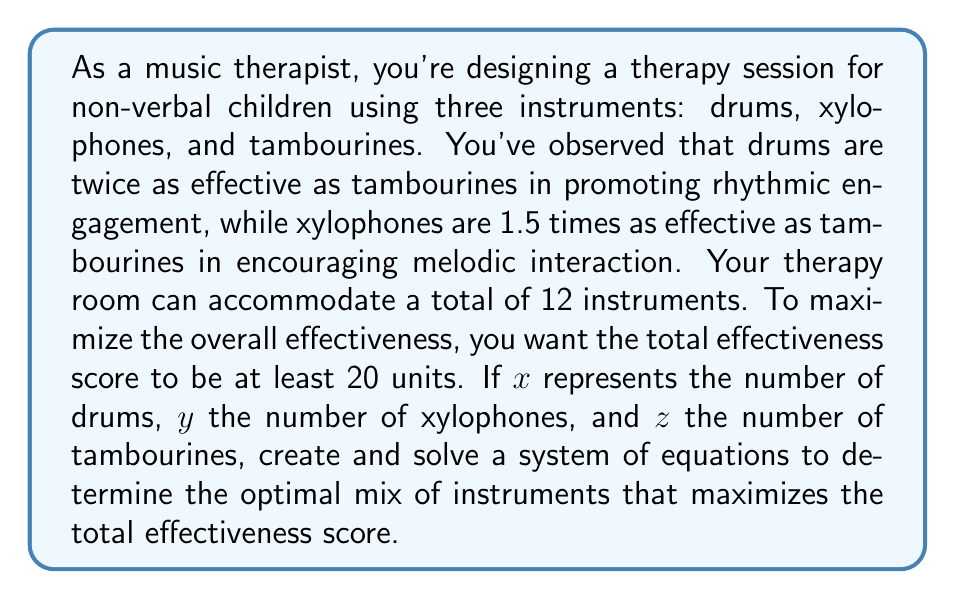Solve this math problem. Let's approach this step-by-step:

1) First, we need to set up our system of equations based on the given information:

   Equation 1 (Total instruments): $x + y + z = 12$
   Equation 2 (Effectiveness score): $2x + 1.5y + z \geq 20$

2) We want to maximize the effectiveness score, so we'll treat the inequality as an equation:
   $2x + 1.5y + z = 20$

3) Now we have a system of two equations with three variables. To solve this, we'll express z in terms of x and y using Equation 1:
   $z = 12 - x - y$

4) Substitute this into Equation 2:
   $2x + 1.5y + (12 - x - y) = 20$

5) Simplify:
   $2x + 1.5y + 12 - x - y = 20$
   $x + 0.5y = 8$

6) Now we have a linear equation in terms of x and y. We want to maximize this, so we'll consider the extreme cases:

   If $x = 0$, then $y = 16$ (which exceeds our total of 12 instruments)
   If $y = 0$, then $x = 8$

7) Since we can't use 16 xylophones, let's start from 8 drums and reduce until we can add xylophones:

   7 drums: $7 + 0.5y = 8$, so $y = 2$
   $z = 12 - 7 - 2 = 3$

8) Check if this satisfies our effectiveness score:
   $2(7) + 1.5(2) + 1(3) = 14 + 3 + 3 = 20$

This solution maximizes the effectiveness score while using all 12 available instrument slots.
Answer: 7 drums, 2 xylophones, 3 tambourines 